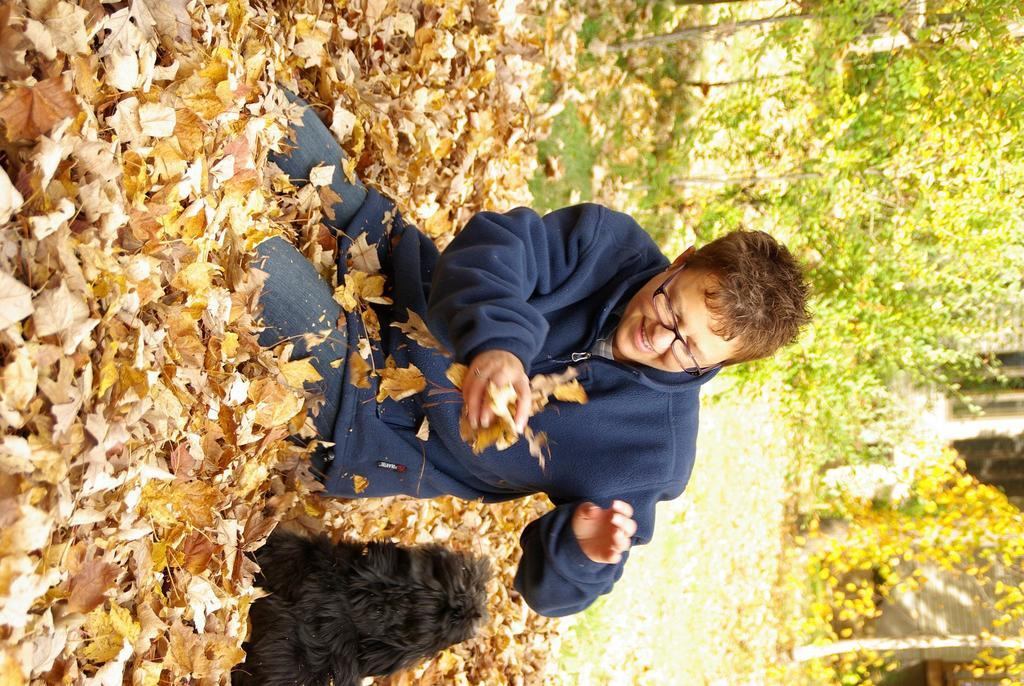What can be seen in the foreground of the image? There is a person and an animal in the foreground of the image. What is the ground made of in the foreground? The foreground contains dry leaves. What can be seen in the background of the image? There are trees, a wall, and windows visible in the background of the image. What is the name of the attraction in the image? There is no attraction mentioned or visible in the image. Can you identify the crow in the image? There is no crow present in the image. 